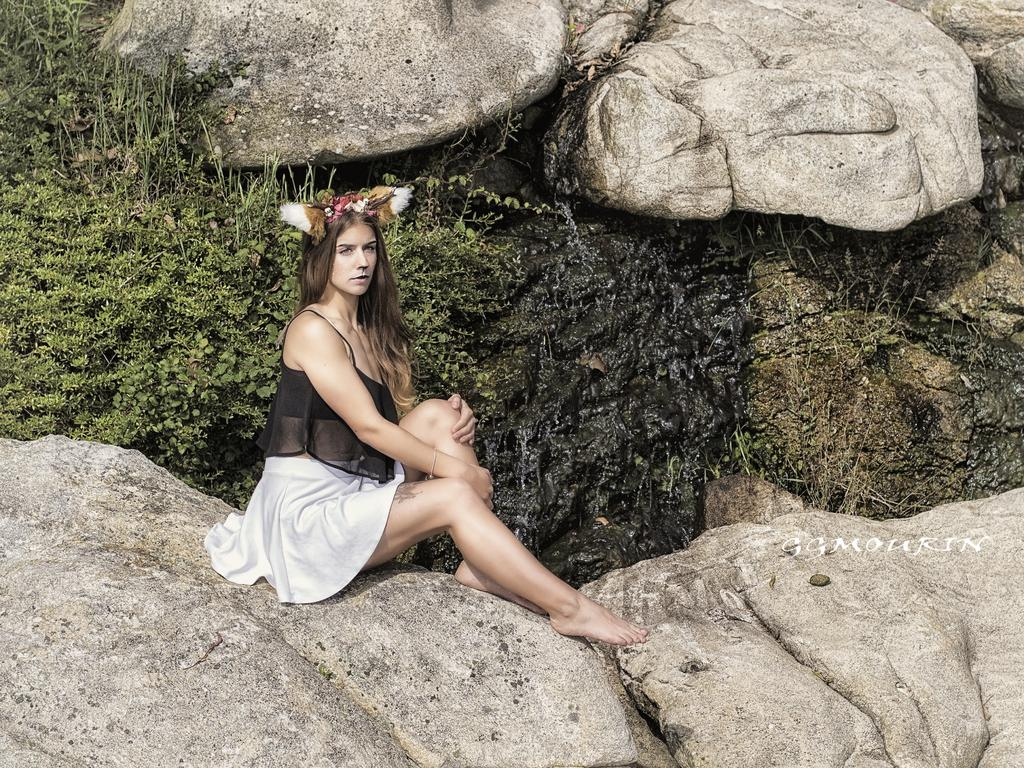Who is the main subject in the image? There is a girl in the image. What is the girl doing in the image? The girl is sitting on a rock. What type of vegetation is visible behind the girl? There is grass behind the girl. What else can be seen behind the girl? There are rocks behind the girl. What type of wrench is the girl using to fix the railway in the image? There is no wrench or railway present in the image; it features a girl sitting on a rock with grass and rocks behind her. 